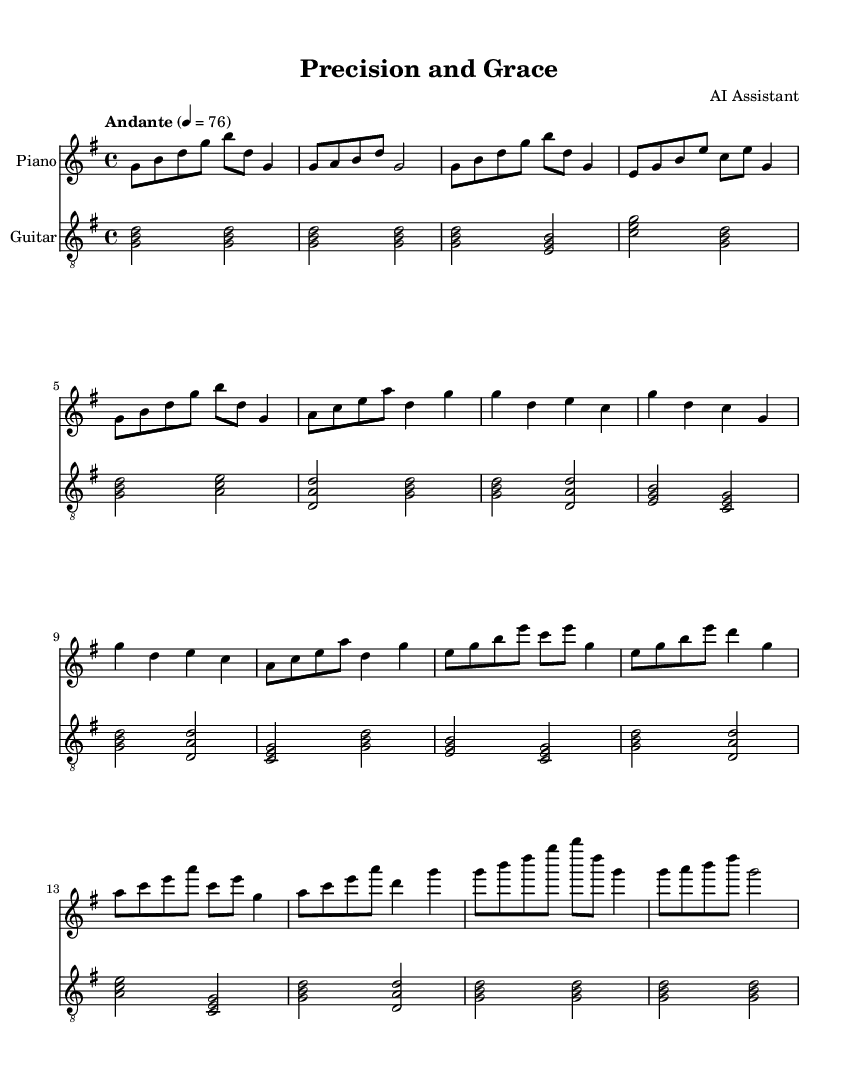What is the key signature of this music? The key signature indicated is G major, which has one sharp (F#). This can be determined from the initial part of the musical notation where the key is specified.
Answer: G major What is the time signature of this music? The time signature is 4/4, which shows that there are four beats in each measure and the quarter note gets one beat. This is visible in the beginning of the sheet music.
Answer: 4/4 What is the tempo marking for this piece? The tempo marking is "Andante," which means a moderately slow tempo. This marking is written prominently at the beginning of the music.
Answer: Andante How many sections are there in the music? The music is divided into five identifiable sections: Intro, Verse, Chorus, Bridge, and Outro. Each section can be recognized by the descriptive labels in the score.
Answer: Five In which section does the change to harmony occur? The harmony change occurs in the Chorus, which features a shift in the chord structure and melody. The transition is apparent when comparing the previous sections to the Chorus.
Answer: Chorus What is the final chord used in the Outro? The final chord in the Outro is a G major chord, established by the notes G, B, and D. This can be inferred from the last measure of the score, where the music ends.
Answer: G major Which instrument is playing the simplified part? The guitar is playing the simplified part, as indicated by the staff labeled with “Guitar.” This section includes a straightforward arpeggiated chord pattern.
Answer: Guitar 